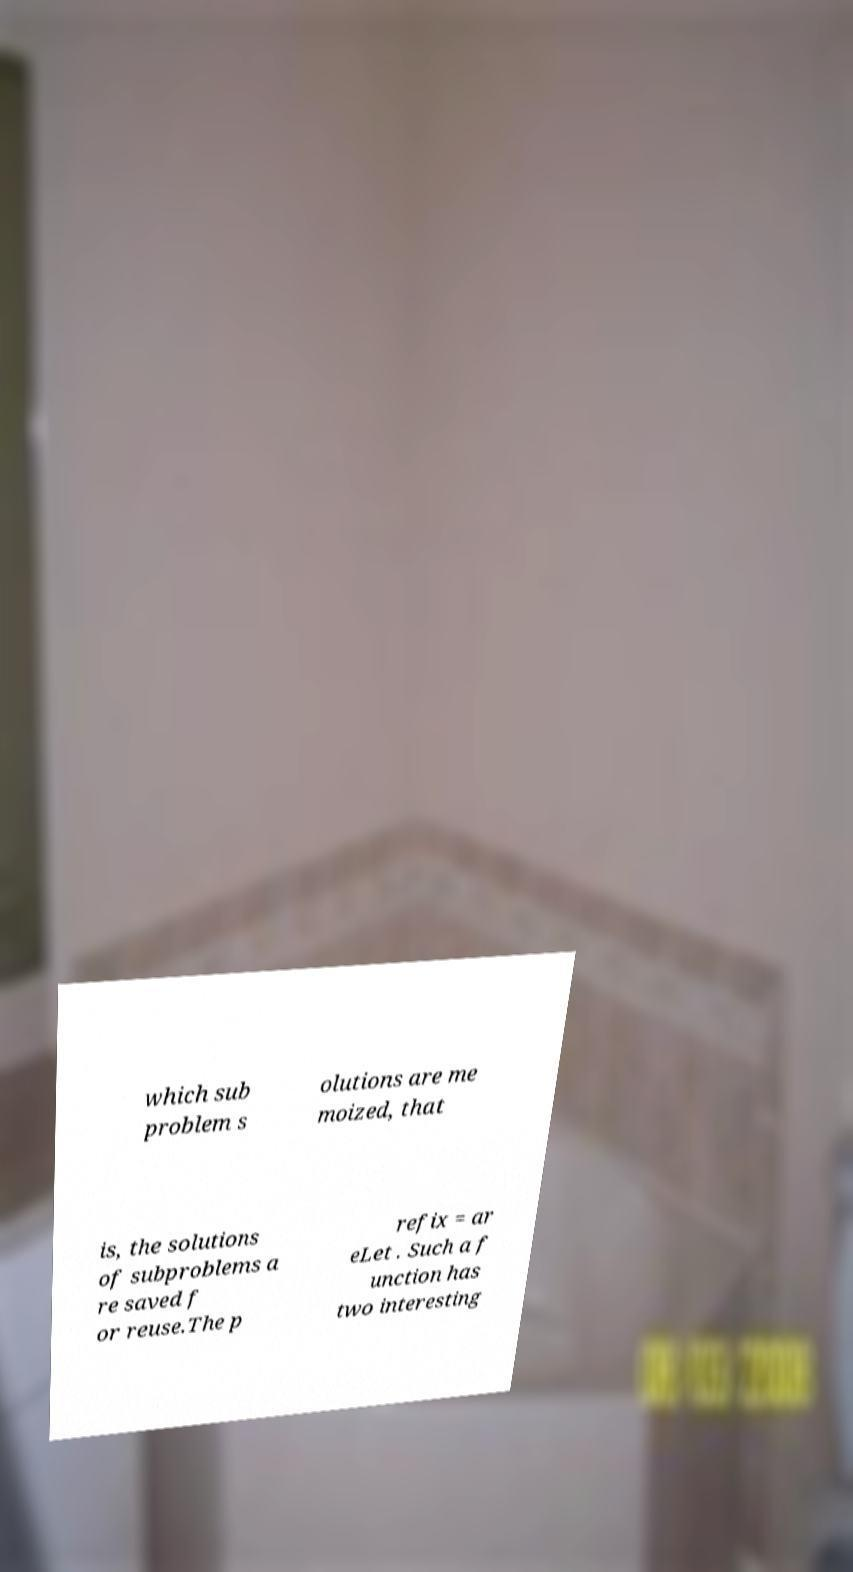There's text embedded in this image that I need extracted. Can you transcribe it verbatim? which sub problem s olutions are me moized, that is, the solutions of subproblems a re saved f or reuse.The p refix = ar eLet . Such a f unction has two interesting 